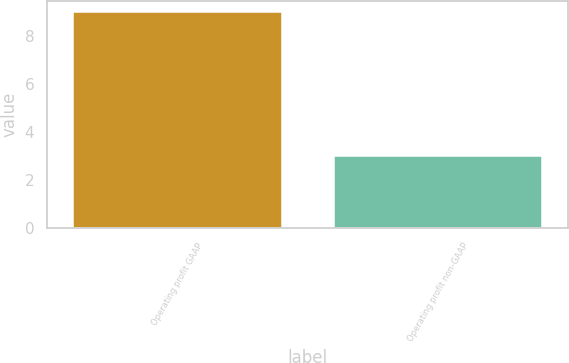Convert chart to OTSL. <chart><loc_0><loc_0><loc_500><loc_500><bar_chart><fcel>Operating profit GAAP<fcel>Operating profit non-GAAP<nl><fcel>9<fcel>3<nl></chart> 